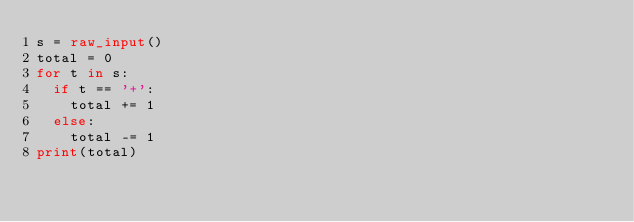Convert code to text. <code><loc_0><loc_0><loc_500><loc_500><_Python_>s = raw_input()
total = 0
for t in s:
  if t == '+':
    total += 1
  else:
    total -= 1
print(total)
</code> 